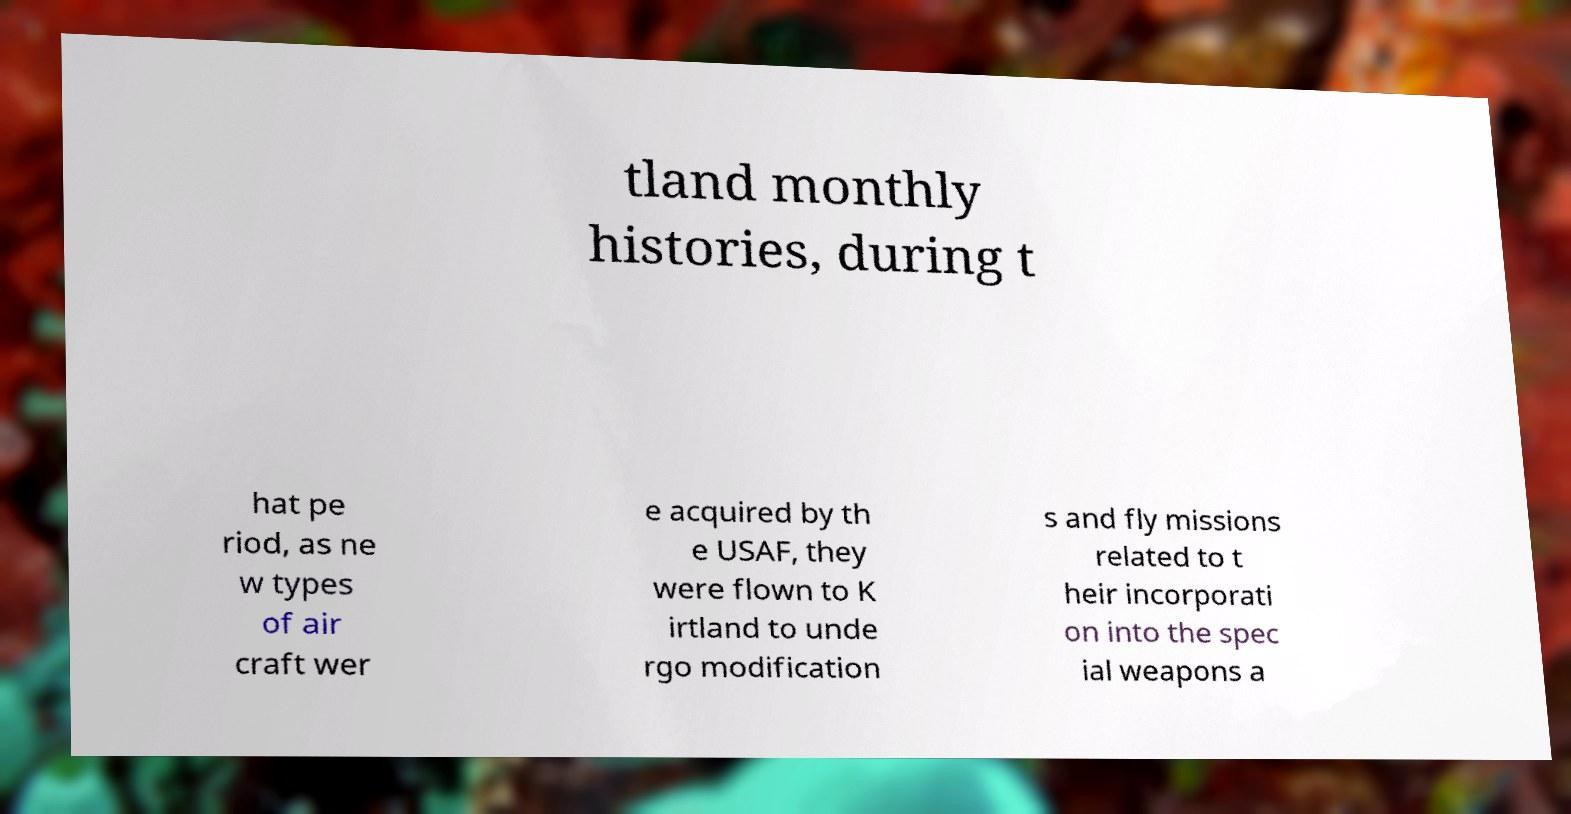Please read and relay the text visible in this image. What does it say? tland monthly histories, during t hat pe riod, as ne w types of air craft wer e acquired by th e USAF, they were flown to K irtland to unde rgo modification s and fly missions related to t heir incorporati on into the spec ial weapons a 